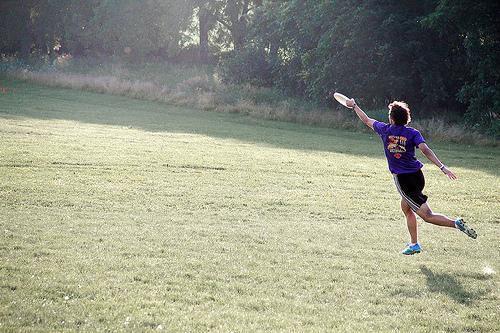How many people are there?
Give a very brief answer. 1. 